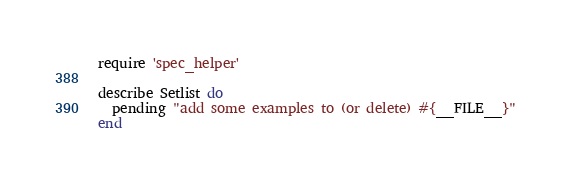<code> <loc_0><loc_0><loc_500><loc_500><_Ruby_>require 'spec_helper'

describe Setlist do
  pending "add some examples to (or delete) #{__FILE__}"
end
</code> 